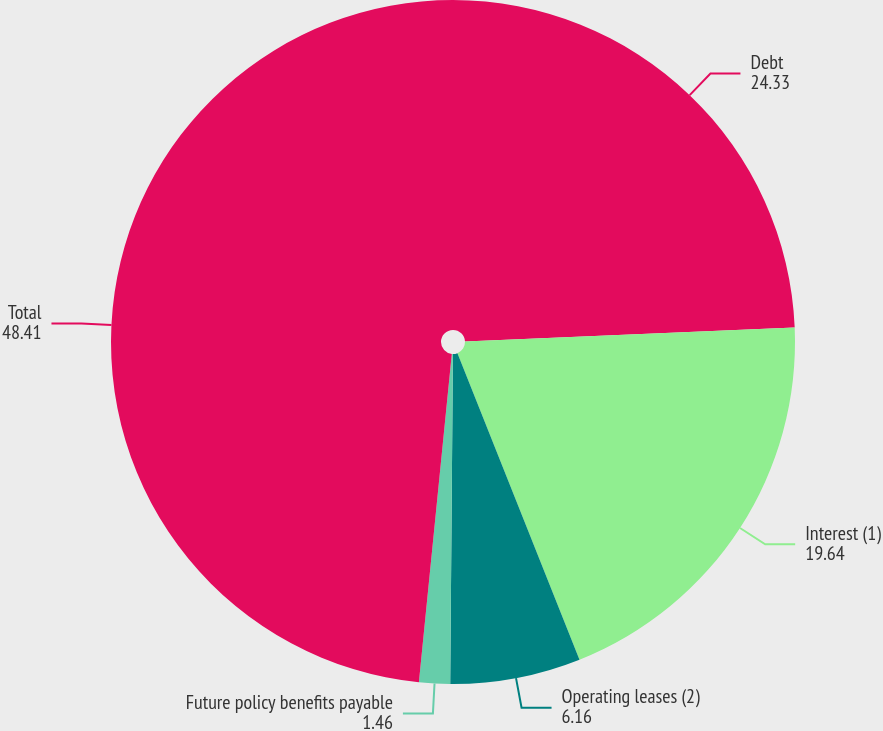<chart> <loc_0><loc_0><loc_500><loc_500><pie_chart><fcel>Debt<fcel>Interest (1)<fcel>Operating leases (2)<fcel>Future policy benefits payable<fcel>Total<nl><fcel>24.33%<fcel>19.64%<fcel>6.16%<fcel>1.46%<fcel>48.41%<nl></chart> 